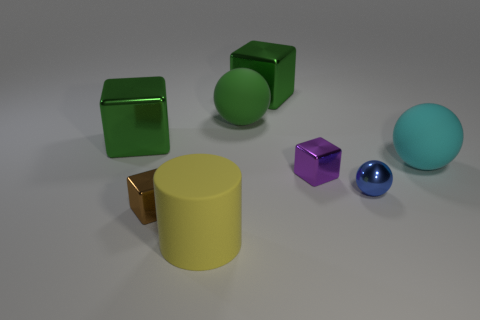What color is the rubber cylinder that is the same size as the cyan rubber object? The rubber cylinder that shares the same size as the cyan object is yellow. This particular shade of yellow on the rubber cylinder has a matte finish, providing a contrast against the shiny surface of the cyan sphere next to it. 